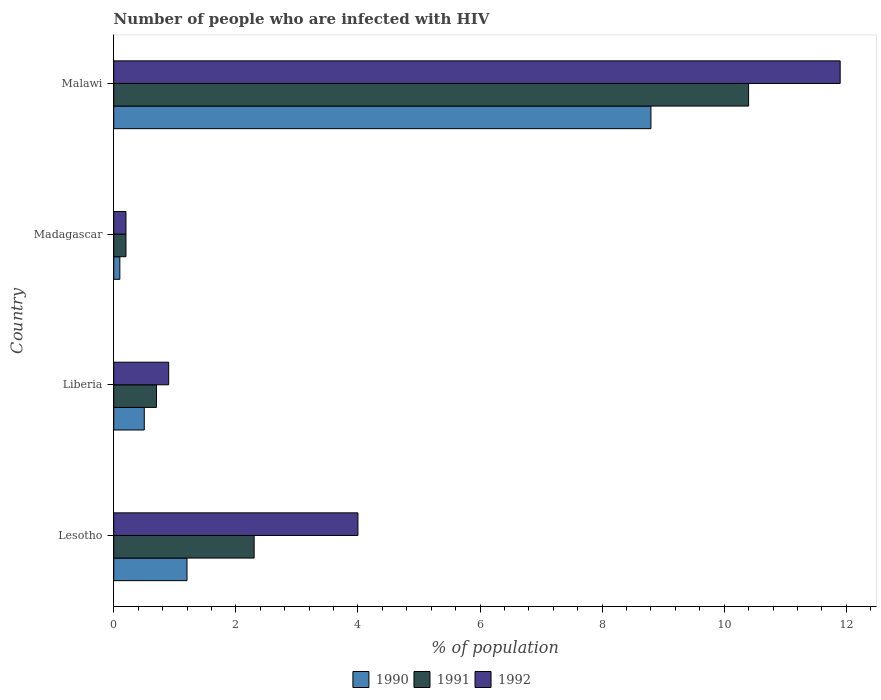How many groups of bars are there?
Your answer should be compact. 4. Are the number of bars per tick equal to the number of legend labels?
Your answer should be compact. Yes. Are the number of bars on each tick of the Y-axis equal?
Your response must be concise. Yes. How many bars are there on the 4th tick from the bottom?
Keep it short and to the point. 3. What is the label of the 1st group of bars from the top?
Keep it short and to the point. Malawi. Across all countries, what is the minimum percentage of HIV infected population in in 1990?
Provide a succinct answer. 0.1. In which country was the percentage of HIV infected population in in 1991 maximum?
Ensure brevity in your answer.  Malawi. In which country was the percentage of HIV infected population in in 1990 minimum?
Provide a short and direct response. Madagascar. What is the total percentage of HIV infected population in in 1992 in the graph?
Provide a short and direct response. 17. What is the average percentage of HIV infected population in in 1991 per country?
Make the answer very short. 3.4. What is the difference between the percentage of HIV infected population in in 1992 and percentage of HIV infected population in in 1990 in Lesotho?
Your answer should be compact. 2.8. In how many countries, is the percentage of HIV infected population in in 1992 greater than 9.6 %?
Provide a succinct answer. 1. What is the ratio of the percentage of HIV infected population in in 1990 in Lesotho to that in Liberia?
Offer a very short reply. 2.4. Is the percentage of HIV infected population in in 1990 in Lesotho less than that in Madagascar?
Keep it short and to the point. No. What is the difference between the highest and the second highest percentage of HIV infected population in in 1992?
Ensure brevity in your answer.  7.9. What is the difference between the highest and the lowest percentage of HIV infected population in in 1992?
Provide a short and direct response. 11.7. In how many countries, is the percentage of HIV infected population in in 1991 greater than the average percentage of HIV infected population in in 1991 taken over all countries?
Provide a short and direct response. 1. Is it the case that in every country, the sum of the percentage of HIV infected population in in 1992 and percentage of HIV infected population in in 1991 is greater than the percentage of HIV infected population in in 1990?
Provide a short and direct response. Yes. What is the difference between two consecutive major ticks on the X-axis?
Provide a succinct answer. 2. Are the values on the major ticks of X-axis written in scientific E-notation?
Your answer should be compact. No. Does the graph contain any zero values?
Give a very brief answer. No. Does the graph contain grids?
Your response must be concise. No. How are the legend labels stacked?
Give a very brief answer. Horizontal. What is the title of the graph?
Ensure brevity in your answer.  Number of people who are infected with HIV. Does "1974" appear as one of the legend labels in the graph?
Provide a succinct answer. No. What is the label or title of the X-axis?
Ensure brevity in your answer.  % of population. What is the % of population of 1990 in Lesotho?
Make the answer very short. 1.2. What is the % of population in 1991 in Lesotho?
Make the answer very short. 2.3. What is the % of population in 1990 in Liberia?
Offer a very short reply. 0.5. What is the % of population in 1992 in Liberia?
Keep it short and to the point. 0.9. What is the % of population of 1990 in Madagascar?
Your response must be concise. 0.1. What is the % of population in 1990 in Malawi?
Provide a short and direct response. 8.8. What is the % of population in 1991 in Malawi?
Offer a terse response. 10.4. What is the % of population of 1992 in Malawi?
Offer a very short reply. 11.9. Across all countries, what is the maximum % of population of 1990?
Provide a short and direct response. 8.8. Across all countries, what is the minimum % of population of 1990?
Offer a terse response. 0.1. What is the difference between the % of population of 1990 in Lesotho and that in Liberia?
Your response must be concise. 0.7. What is the difference between the % of population of 1991 in Lesotho and that in Madagascar?
Offer a terse response. 2.1. What is the difference between the % of population of 1990 in Lesotho and that in Malawi?
Ensure brevity in your answer.  -7.6. What is the difference between the % of population in 1992 in Lesotho and that in Malawi?
Make the answer very short. -7.9. What is the difference between the % of population in 1990 in Liberia and that in Madagascar?
Provide a succinct answer. 0.4. What is the difference between the % of population of 1991 in Liberia and that in Madagascar?
Provide a succinct answer. 0.5. What is the difference between the % of population of 1992 in Liberia and that in Madagascar?
Your response must be concise. 0.7. What is the difference between the % of population of 1990 in Lesotho and the % of population of 1991 in Liberia?
Provide a short and direct response. 0.5. What is the difference between the % of population in 1990 in Lesotho and the % of population in 1992 in Liberia?
Offer a very short reply. 0.3. What is the difference between the % of population in 1990 in Lesotho and the % of population in 1991 in Madagascar?
Provide a short and direct response. 1. What is the difference between the % of population in 1991 in Lesotho and the % of population in 1992 in Madagascar?
Ensure brevity in your answer.  2.1. What is the difference between the % of population in 1990 in Lesotho and the % of population in 1991 in Malawi?
Provide a short and direct response. -9.2. What is the difference between the % of population of 1990 in Lesotho and the % of population of 1992 in Malawi?
Make the answer very short. -10.7. What is the difference between the % of population of 1990 in Liberia and the % of population of 1991 in Madagascar?
Keep it short and to the point. 0.3. What is the difference between the % of population in 1991 in Liberia and the % of population in 1992 in Madagascar?
Your answer should be very brief. 0.5. What is the difference between the % of population in 1990 in Liberia and the % of population in 1991 in Malawi?
Ensure brevity in your answer.  -9.9. What is the difference between the % of population in 1991 in Liberia and the % of population in 1992 in Malawi?
Offer a very short reply. -11.2. What is the difference between the % of population in 1990 in Madagascar and the % of population in 1991 in Malawi?
Keep it short and to the point. -10.3. What is the difference between the % of population of 1990 in Madagascar and the % of population of 1992 in Malawi?
Provide a short and direct response. -11.8. What is the average % of population in 1990 per country?
Your answer should be very brief. 2.65. What is the average % of population in 1991 per country?
Ensure brevity in your answer.  3.4. What is the average % of population of 1992 per country?
Make the answer very short. 4.25. What is the difference between the % of population in 1990 and % of population in 1991 in Lesotho?
Keep it short and to the point. -1.1. What is the difference between the % of population in 1990 and % of population in 1992 in Lesotho?
Offer a terse response. -2.8. What is the difference between the % of population of 1990 and % of population of 1991 in Liberia?
Provide a short and direct response. -0.2. What is the difference between the % of population in 1990 and % of population in 1992 in Liberia?
Provide a succinct answer. -0.4. What is the difference between the % of population of 1991 and % of population of 1992 in Liberia?
Give a very brief answer. -0.2. What is the difference between the % of population of 1990 and % of population of 1991 in Madagascar?
Your answer should be compact. -0.1. What is the difference between the % of population of 1990 and % of population of 1991 in Malawi?
Your answer should be compact. -1.6. What is the ratio of the % of population in 1991 in Lesotho to that in Liberia?
Your answer should be very brief. 3.29. What is the ratio of the % of population of 1992 in Lesotho to that in Liberia?
Offer a terse response. 4.44. What is the ratio of the % of population in 1990 in Lesotho to that in Malawi?
Offer a very short reply. 0.14. What is the ratio of the % of population of 1991 in Lesotho to that in Malawi?
Ensure brevity in your answer.  0.22. What is the ratio of the % of population in 1992 in Lesotho to that in Malawi?
Make the answer very short. 0.34. What is the ratio of the % of population in 1990 in Liberia to that in Madagascar?
Provide a succinct answer. 5. What is the ratio of the % of population of 1992 in Liberia to that in Madagascar?
Ensure brevity in your answer.  4.5. What is the ratio of the % of population of 1990 in Liberia to that in Malawi?
Provide a short and direct response. 0.06. What is the ratio of the % of population in 1991 in Liberia to that in Malawi?
Offer a very short reply. 0.07. What is the ratio of the % of population in 1992 in Liberia to that in Malawi?
Keep it short and to the point. 0.08. What is the ratio of the % of population in 1990 in Madagascar to that in Malawi?
Your answer should be compact. 0.01. What is the ratio of the % of population of 1991 in Madagascar to that in Malawi?
Ensure brevity in your answer.  0.02. What is the ratio of the % of population in 1992 in Madagascar to that in Malawi?
Offer a very short reply. 0.02. What is the difference between the highest and the second highest % of population of 1991?
Make the answer very short. 8.1. What is the difference between the highest and the lowest % of population of 1992?
Offer a very short reply. 11.7. 